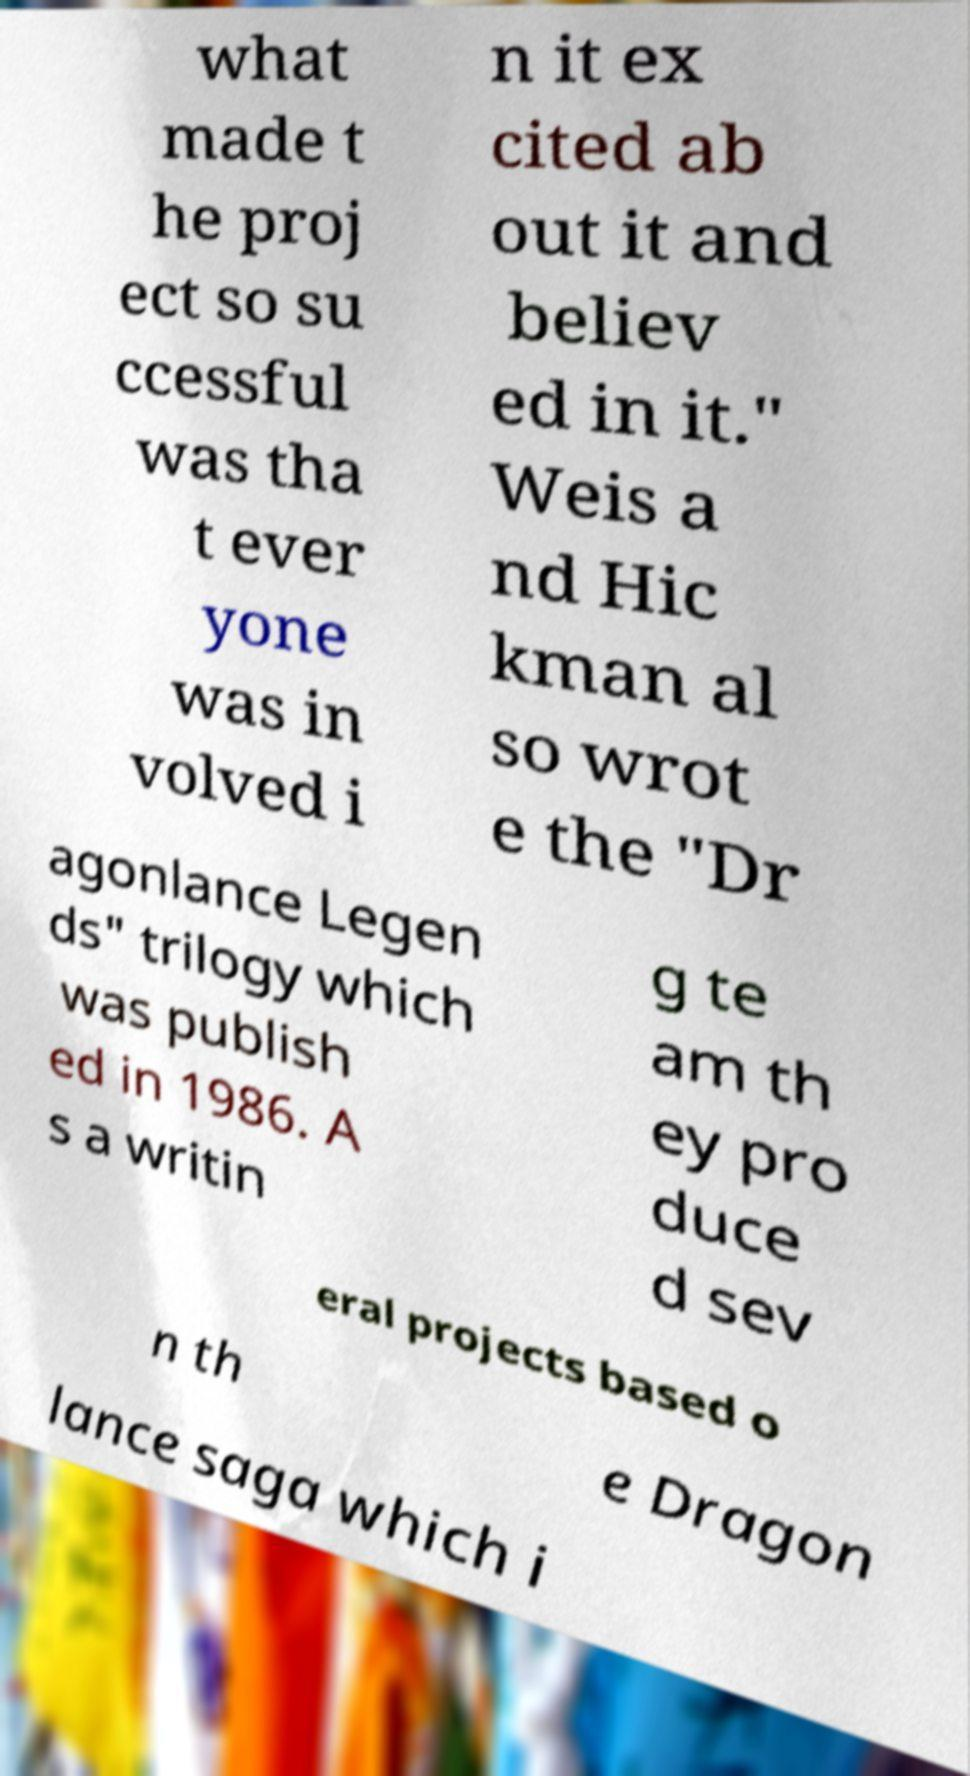For documentation purposes, I need the text within this image transcribed. Could you provide that? what made t he proj ect so su ccessful was tha t ever yone was in volved i n it ex cited ab out it and believ ed in it." Weis a nd Hic kman al so wrot e the "Dr agonlance Legen ds" trilogy which was publish ed in 1986. A s a writin g te am th ey pro duce d sev eral projects based o n th e Dragon lance saga which i 